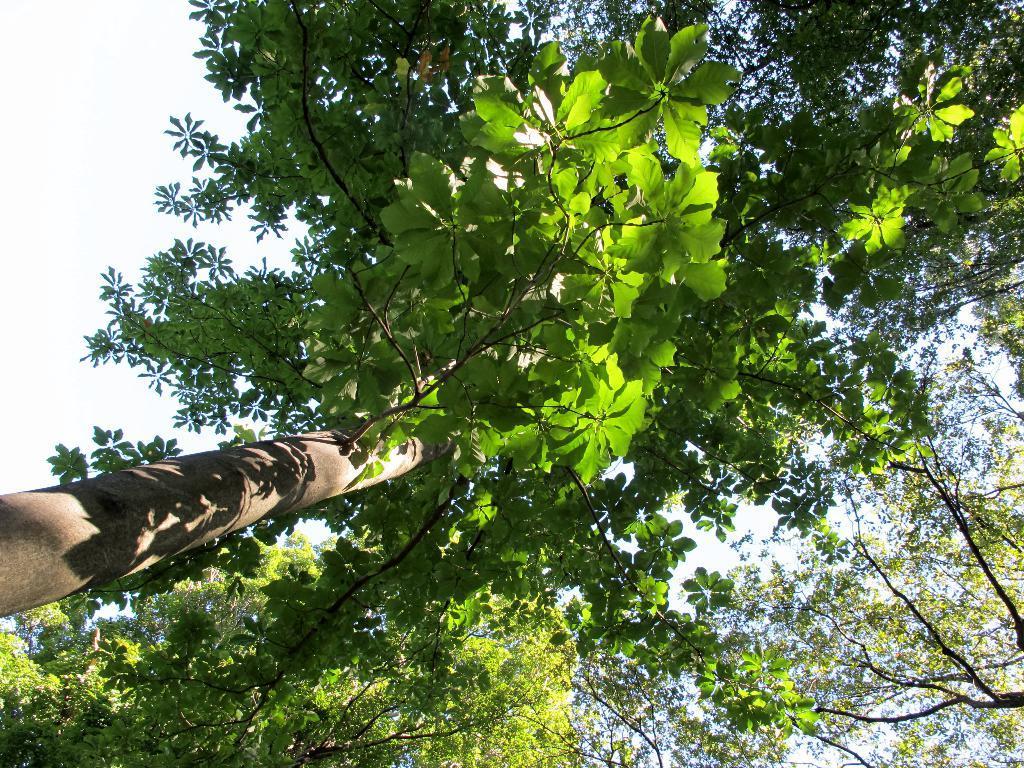Describe this image in one or two sentences. In this picture there are green leaves with brown branches in the foreground. And the is at the top. 